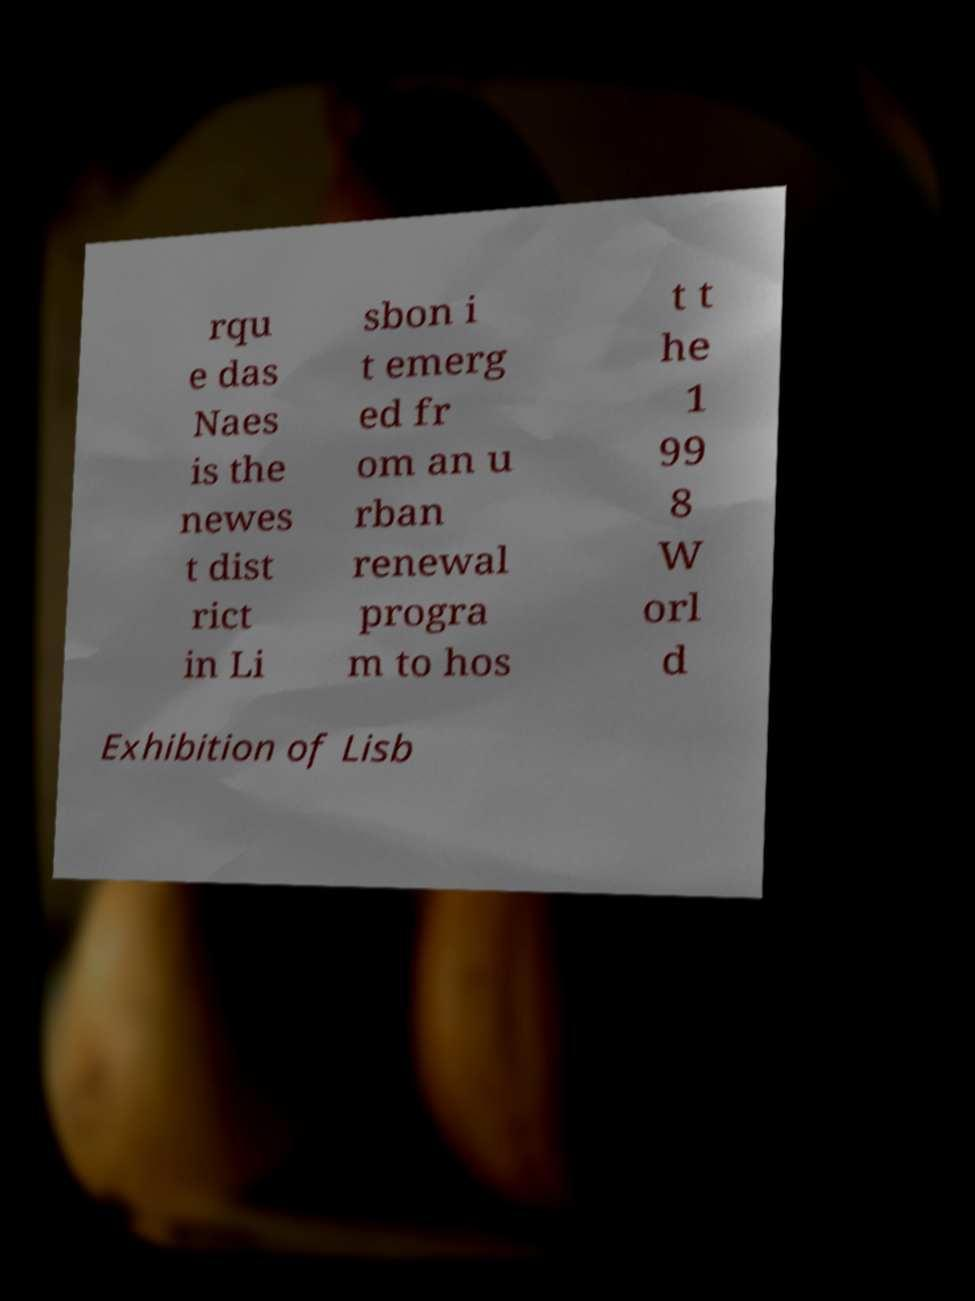Could you assist in decoding the text presented in this image and type it out clearly? rqu e das Naes is the newes t dist rict in Li sbon i t emerg ed fr om an u rban renewal progra m to hos t t he 1 99 8 W orl d Exhibition of Lisb 